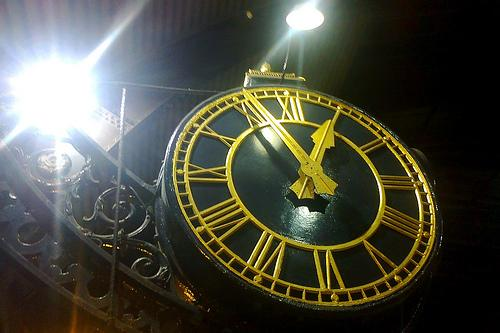Describe the lighting in the image, specifically any fixtures or sources of light mentioned. There are overhead outdoor lights, one of which is bright white and shining in the background. Identify what type of object is the main focus of the image. The main focus of the image is a large outdoor clock with Roman numerals and a black face. List the materials mentioned in the manuscript that are present in the image. Iron, sheet metal, steel, and decorative black metal. Count the number of hands on the clock face and the numerals' design. The clock has two hands and uses Roman numerals for its numbers. Describe the interaction between the clock and any nearby objects in the image. The clock is connected to a black object and is mounted on a decorative iron mount, indicating a functional and aesthetic relationship. Name any prominent design features of the clock and its surroundings in the image. The clock features Roman numerals, gold hands, and is mounted on a decorative black iron mount. Discuss the quality of the image by assessing the clarity of the contents and the lighting. The quality of the image seems to be good with clear descriptions of the contents and mentions of bright lighting. What can you infer about the color and design of the main object in this image? The clock is yellow and black in color, with a round shape and Roman numerals on its face. Based on the given information, what could be the approximate time displayed on the clock? The time on the clock is approximately five minutes to one o'clock. What kind of structure does the clock rest on? A large steel support beam Describe the appearance of the clock numerals. The numerals on the clock are Roman numerals. Is the light in the background shining brightly or dimly? Shining brightly Notice the blue umbrella leaning against the decorative iron mount. No, it's not mentioned in the image. What is the time displayed by the clock? Five minutes to one o'clock What color are the clock's hands? Multiple choices: (a) Gold, (b) Silver, (c) Black, (d) Red a) Gold Name the components that make up the clock. Clock face, hour hand, minute hand, Roman numerals, and decorative metal mount Relate the theme of the image to an event that is happening. The event may be time passing as indicated by the clock hands pointing to five minutes to one. Identify the different colors of objects in the image. Gold hands, black and yellow clock face, and bright white light In the context of the image, what is the meaning of the word "bright"? The intensity of the light from the overhead outdoor light Determine the overall color theme of the clock. Yellow and black Do the hands of the clock have any specific color? Yes, the hands are yellow in color. What is the supporting structure of a roof made of? Iron sheet Identify the materials/colors used in the clock's components. Black clock face, yellow hands with Roman numerals and a gold frame Describe the type of numerals used on the clock face. Roman numerals What type of object is above the clock and casting light? Overhead outdoor light What can you tell about the clock's shape and its face? The clock is round in shape and has a dark face with Roman numerals. Describe the emotions or moods expressed by the objects in the image. No emotions or moods expressed. What can you tell about the material of the clock's face? The clock face is shiny What kind of metalwork is surrounding the clock? Decorative black metal Can you spot the orange cat sitting on the steel support beam? There isn't actually a cat in the image, but the mention of a specific color and location makes it sound convincing. 